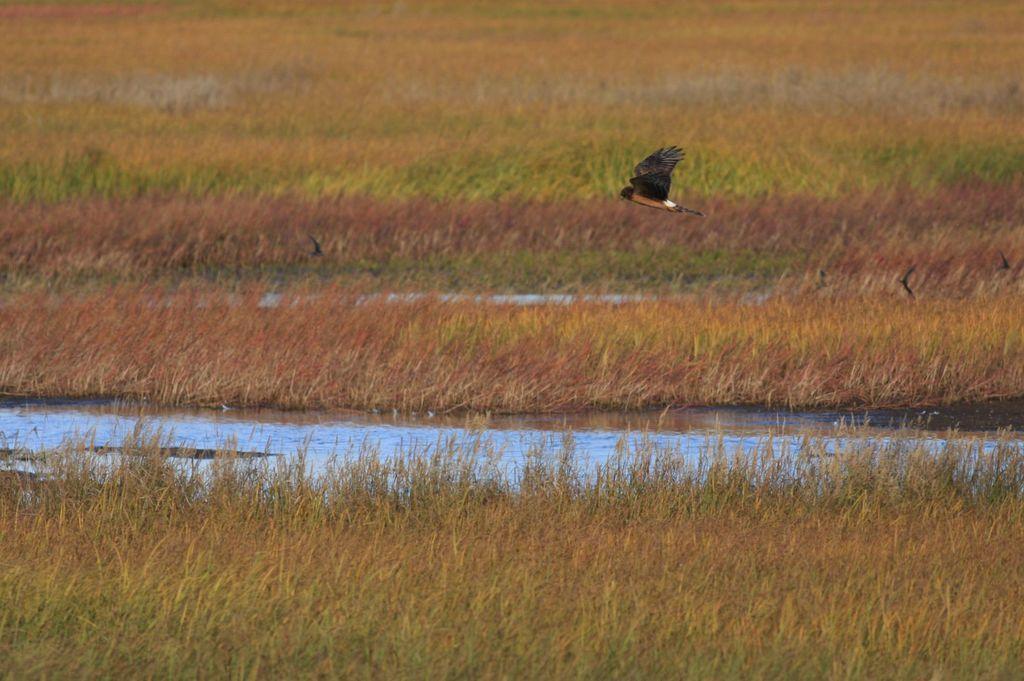Can you describe this image briefly? In this image there is a bird flying in the air. There is water. Background there is grassland. 